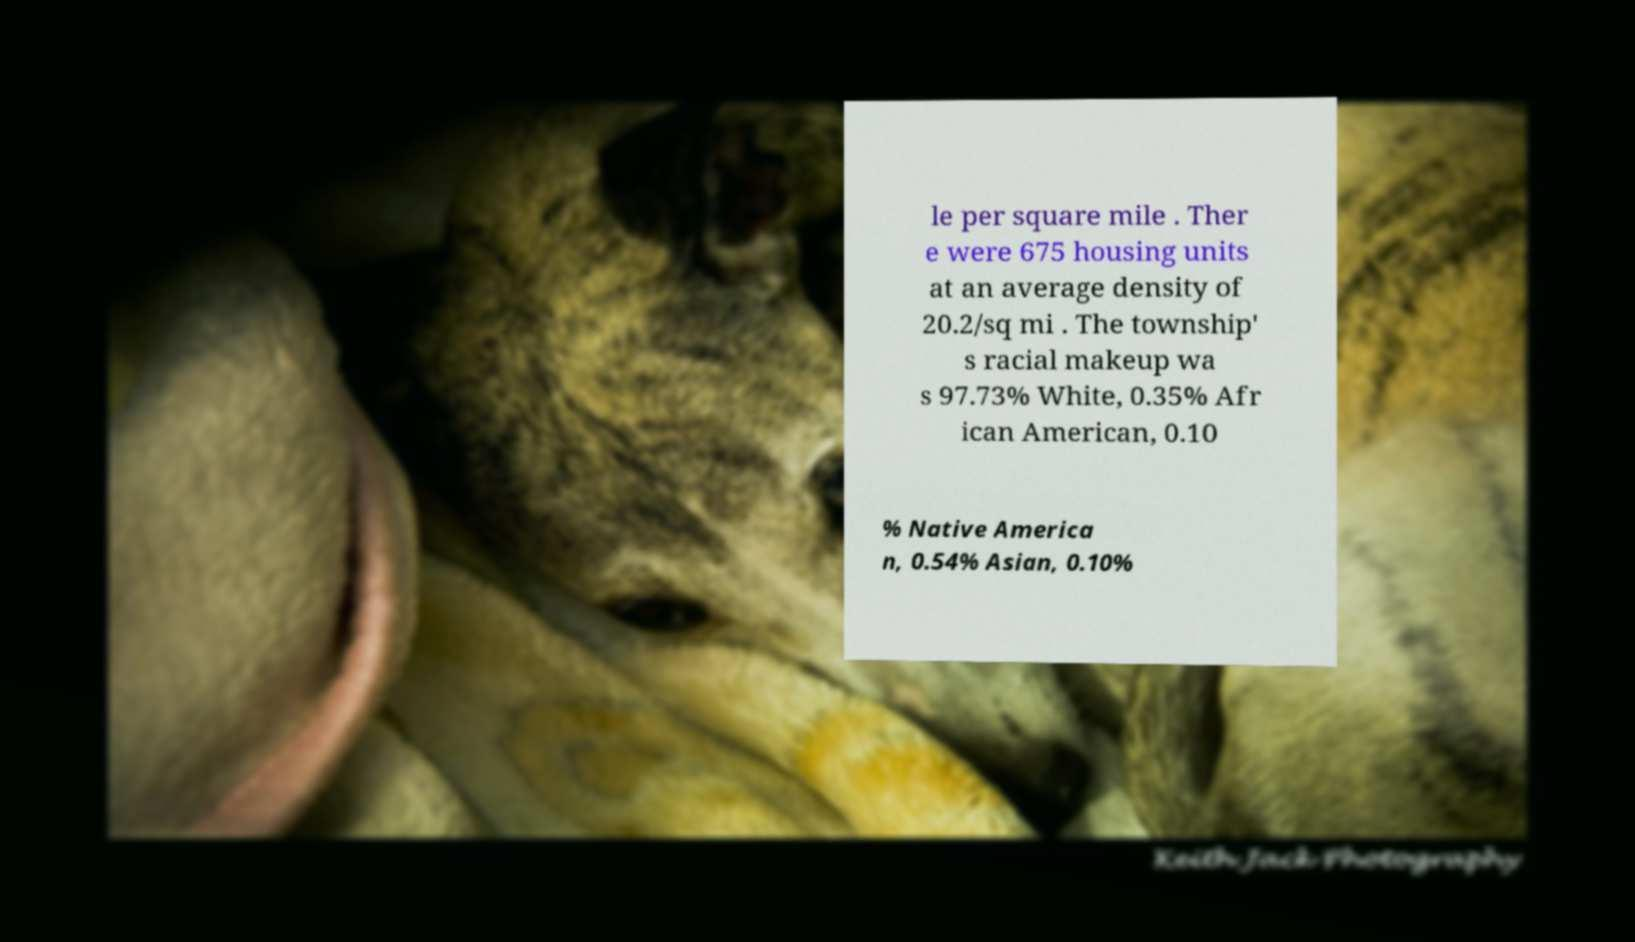Could you assist in decoding the text presented in this image and type it out clearly? le per square mile . Ther e were 675 housing units at an average density of 20.2/sq mi . The township' s racial makeup wa s 97.73% White, 0.35% Afr ican American, 0.10 % Native America n, 0.54% Asian, 0.10% 